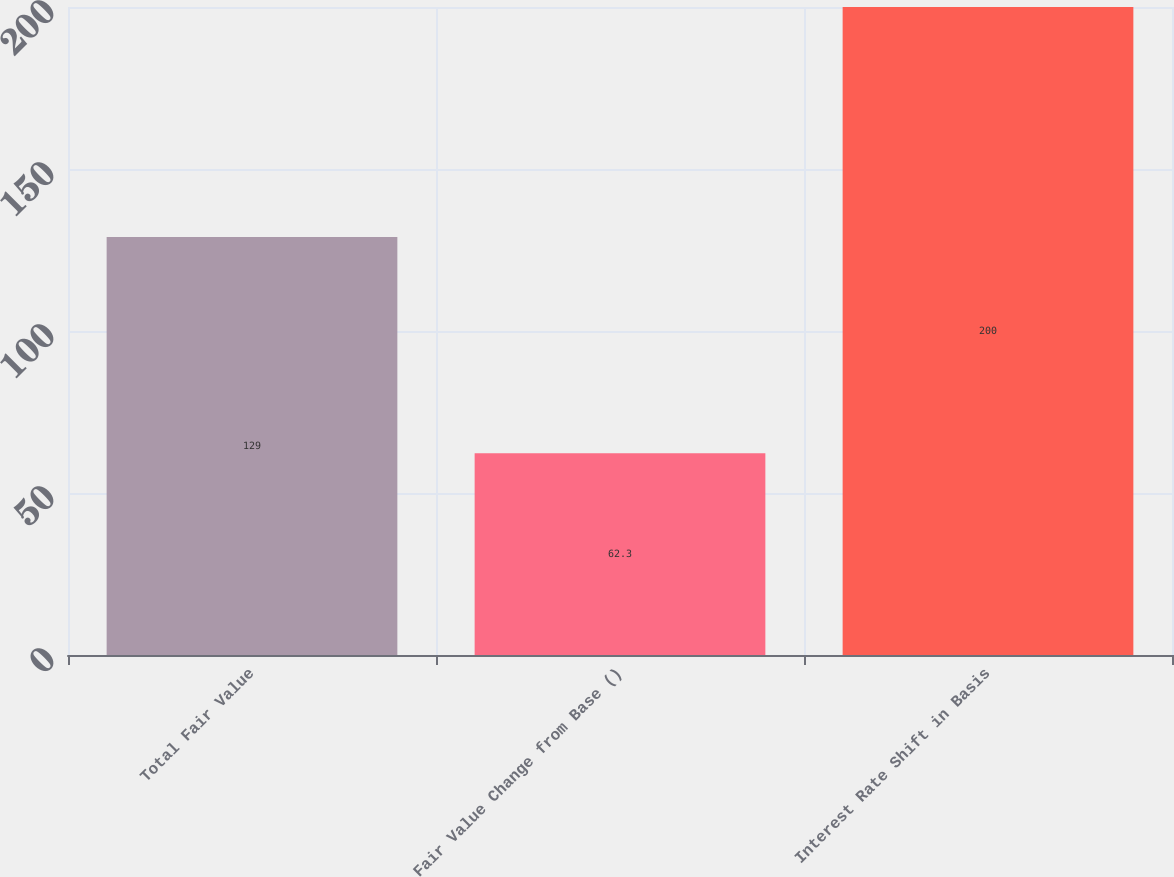<chart> <loc_0><loc_0><loc_500><loc_500><bar_chart><fcel>Total Fair Value<fcel>Fair Value Change from Base ()<fcel>Interest Rate Shift in Basis<nl><fcel>129<fcel>62.3<fcel>200<nl></chart> 